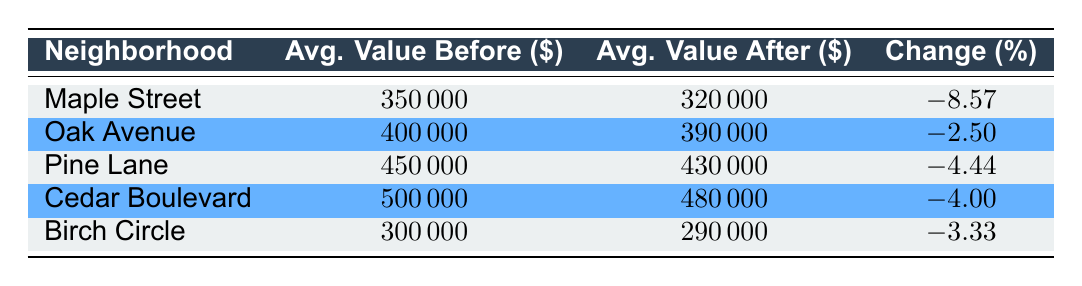What was the average property value on Maple Street before the club opened? According to the table, the average property value on Maple Street before the club opened was listed as 350,000 dollars.
Answer: 350000 What is the percentage change in property values on Oak Avenue? The table shows the percentage change in property values on Oak Avenue as -2.5%. This means property values decreased by that percentage after the club opened.
Answer: -2.5 Which neighborhood had the highest average property value after the club opened? By comparing the average values after the club opened, Cedar Boulevard (480,000 dollars) has the highest average property value.
Answer: Cedar Boulevard What is the difference in average property values before and after the club opened for Pine Lane? The average value before the club opened for Pine Lane was 450,000 dollars and 430,000 dollars after the club opened. The difference is 450,000 - 430,000 = 20,000 dollars.
Answer: 20000 Is it true that Birch Circle experienced a decrease in property value after the club opened? Yes, Birch Circle had an average property value of 300,000 dollars before and 290,000 dollars after the club opened, indicating a decrease.
Answer: Yes Which neighborhood experienced the largest percentage decrease in property value? By examining the percentage changes, Maple Street experienced the largest decrease at -8.57%, which is greater than the decreases in other neighborhoods.
Answer: Maple Street What was the average property value of all neighborhoods before the club opened? To find the average, we sum the average values before: (350000 + 400000 + 450000 + 500000 + 300000) = 2000000 dollars and divide by 5 neighborhoods, giving us 2000000/5 = 400000 dollars.
Answer: 400000 What is the average percentage change across all neighborhoods? The average percentage change is calculated by taking the sum of the percentage changes: (-8.57 - 2.5 - 4.44 - 4.0 - 3.33) = -22.84% and dividing by 5 neighborhoods to get an average of -4.568%. Thus, we can conclude that property values generally decreased.
Answer: -4.568 Did Cedar Boulevard's property values increase after the club opened? No, Cedar Boulevard's average value decreased from 500,000 dollars to 480,000 dollars after the club opened, showing a decline.
Answer: No 